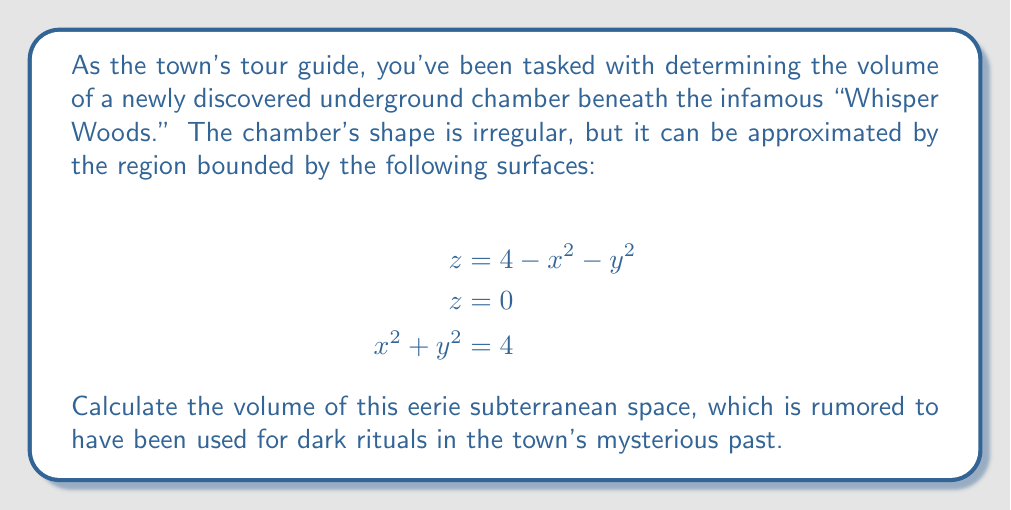Provide a solution to this math problem. To determine the volume of this irregularly shaped underground chamber, we need to set up and evaluate a triple integral. Let's approach this step-by-step:

1) First, we need to identify the limits of integration. The chamber is bounded by a circular region in the xy-plane ($$x^2 + y^2 = 4$$) and extends from $$z = 0$$ to $$z = 4 - x^2 - y^2$$.

2) Due to the circular symmetry in the xy-plane, it's advisable to use cylindrical coordinates. Let's convert our equations:
   $$x = r\cos\theta$$
   $$y = r\sin\theta$$
   $$x^2 + y^2 = r^2$$

3) In cylindrical coordinates, our bounds become:
   $$0 \leq r \leq 2$$ (from $$x^2 + y^2 = 4$$)
   $$0 \leq \theta \leq 2\pi$$
   $$0 \leq z \leq 4 - r^2$$

4) The volume integral in cylindrical coordinates is:

   $$V = \int_0^{2\pi} \int_0^2 \int_0^{4-r^2} r \, dz \, dr \, d\theta$$

5) Let's evaluate the integral from inside out:

   $$V = \int_0^{2\pi} \int_0^2 r(4-r^2) \, dr \, d\theta$$

6) Integrate with respect to r:

   $$V = \int_0^{2\pi} \left[2r^2 - \frac{r^4}{4}\right]_0^2 \, d\theta$$
   $$= \int_0^{2\pi} \left(8 - 1\right) \, d\theta$$
   $$= \int_0^{2\pi} 7 \, d\theta$$

7) Finally, integrate with respect to θ:

   $$V = 7\theta \bigg|_0^{2\pi} = 14\pi$$

Therefore, the volume of the underground chamber is $$14\pi$$ cubic units.
Answer: $$14\pi$$ cubic units 